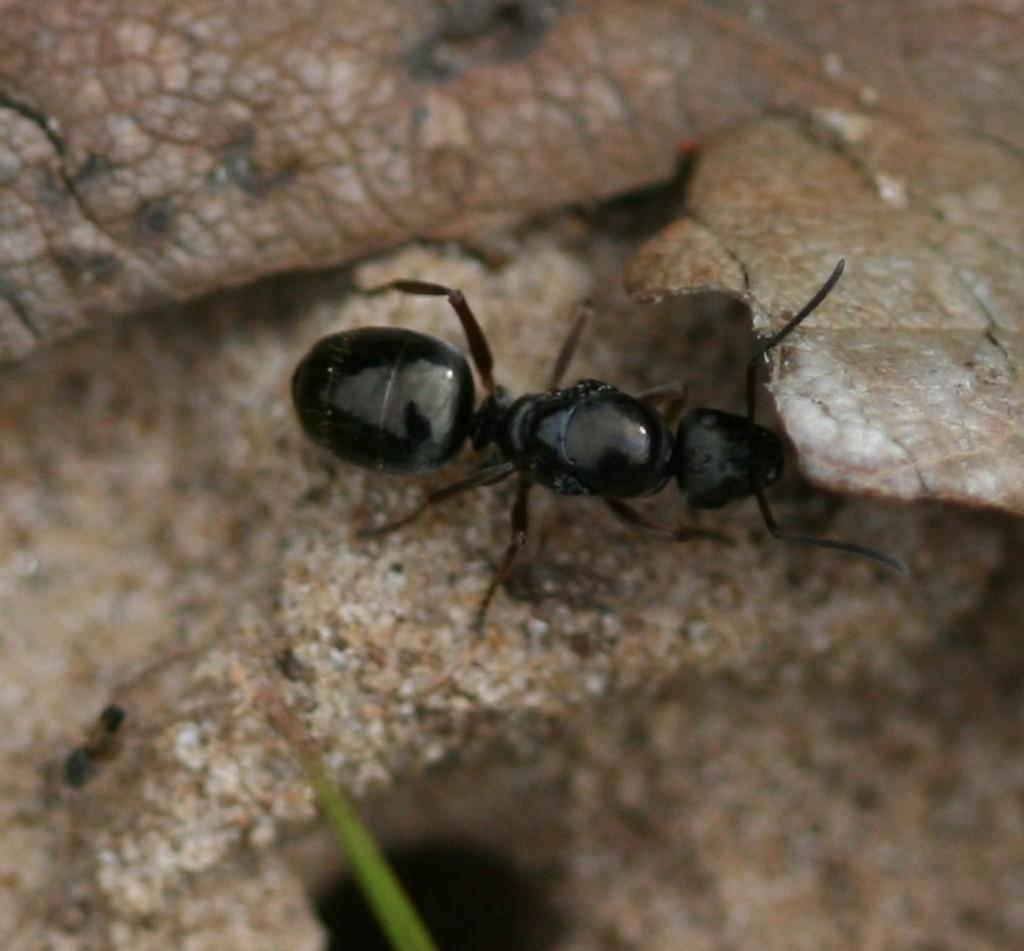What type of creature is present in the image? There is an insect in the image. What is the color of the insect? The insect is black in color. What is the insect resting on in the image? The insect is on a brown surface. What other color can be seen in the image besides black and brown? There is an object in the image that is green in color. How many horses are visible in the image? There are no horses present in the image; it features an insect on a brown surface and a green object. 